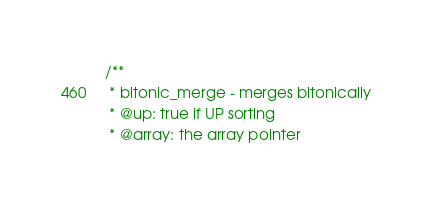Convert code to text. <code><loc_0><loc_0><loc_500><loc_500><_C_>/**
 * bitonic_merge - merges bitonically
 * @up: true if UP sorting
 * @array: the array pointer</code> 